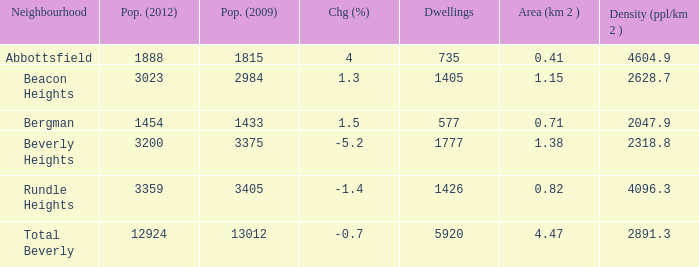How many Dwellings does Beverly Heights have that have a change percent larger than -5.2? None. 